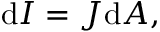<formula> <loc_0><loc_0><loc_500><loc_500>d I = J { d A } , \,</formula> 